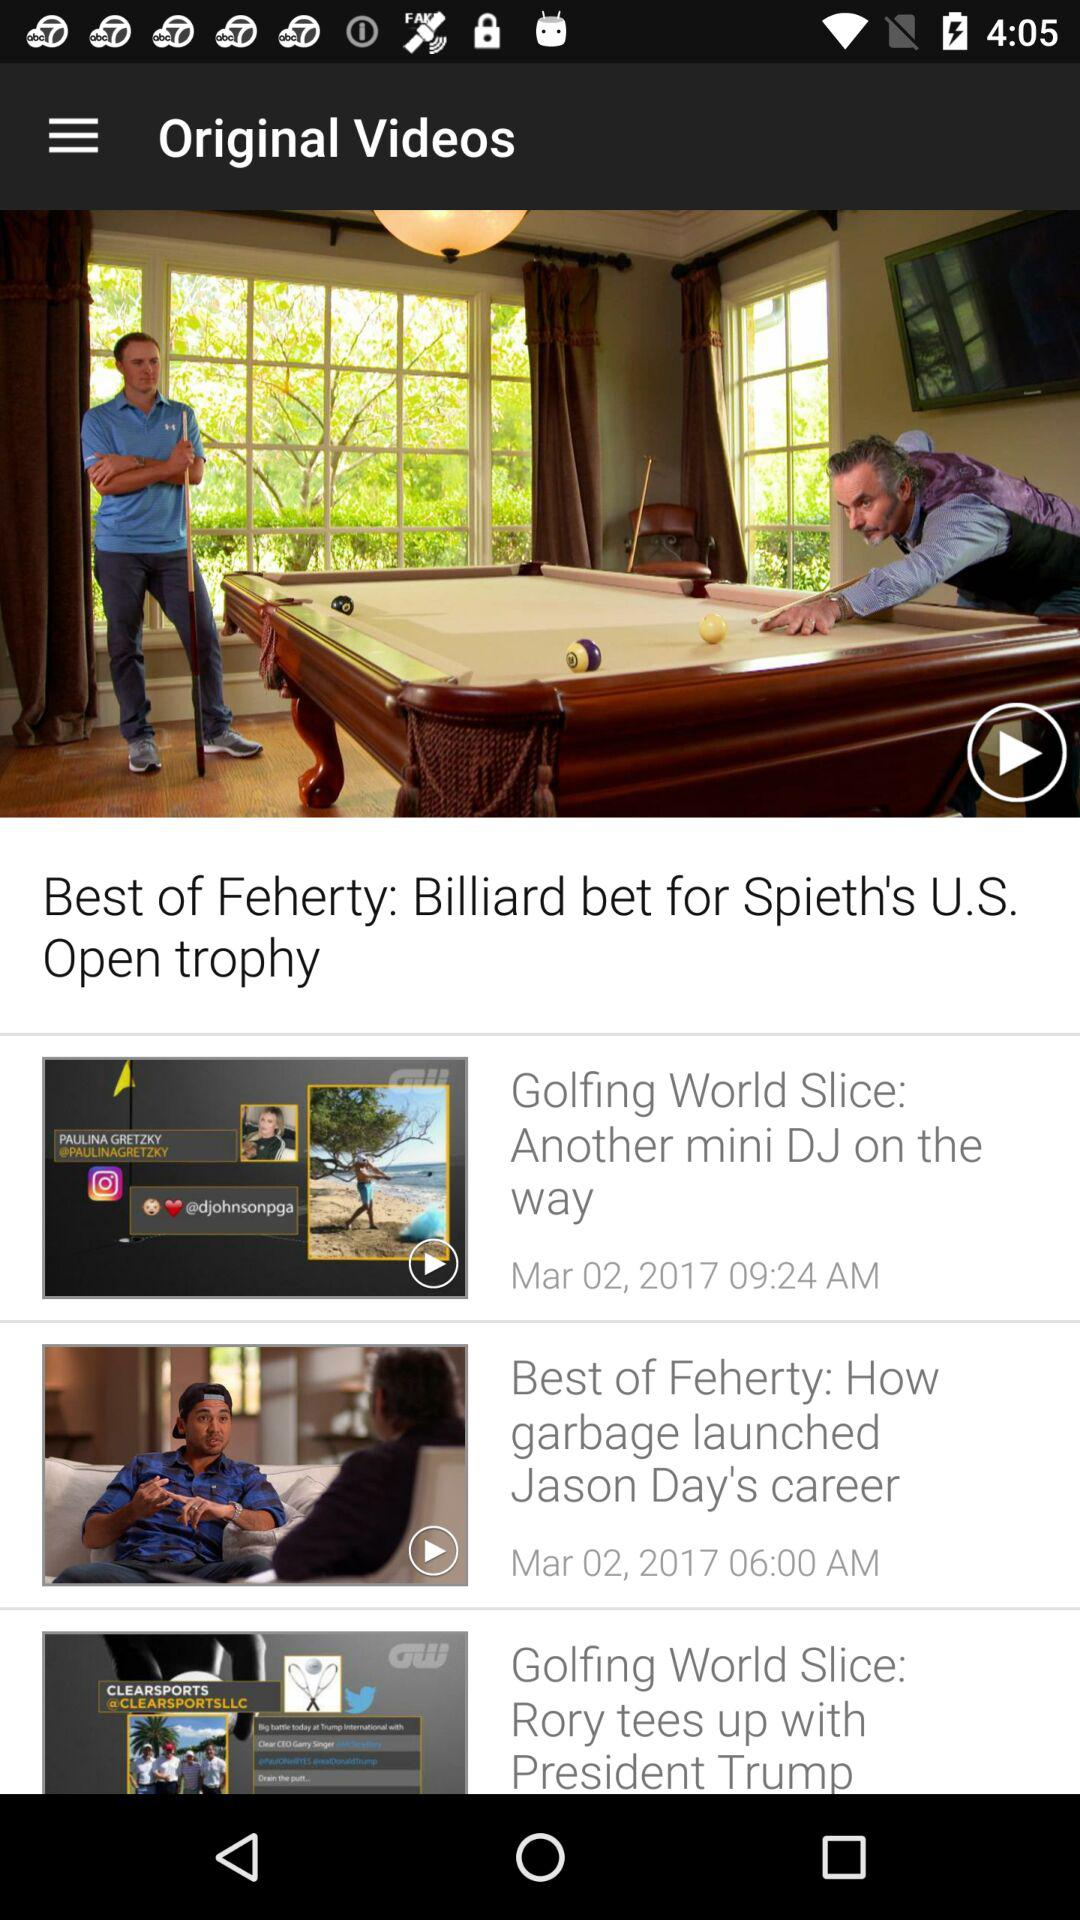What is the name of the video posted on March 2, 2017 at 6:00 a.m.? The name of the video posted on March 2, 2017 at 6:00 a.m. is "Best of Feherty: How garbage launched Jason Day's career". 